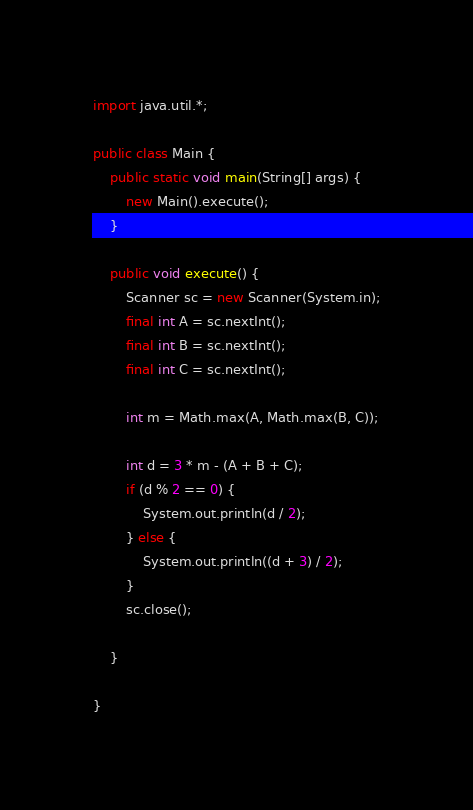Convert code to text. <code><loc_0><loc_0><loc_500><loc_500><_Java_>import java.util.*;

public class Main {
	public static void main(String[] args) {
		new Main().execute();
	}

	public void execute() {
		Scanner sc = new Scanner(System.in);
		final int A = sc.nextInt();
		final int B = sc.nextInt();
		final int C = sc.nextInt();

		int m = Math.max(A, Math.max(B, C));

		int d = 3 * m - (A + B + C);
		if (d % 2 == 0) {
			System.out.println(d / 2);
		} else {
			System.out.println((d + 3) / 2);
		}
		sc.close();

	}

}</code> 